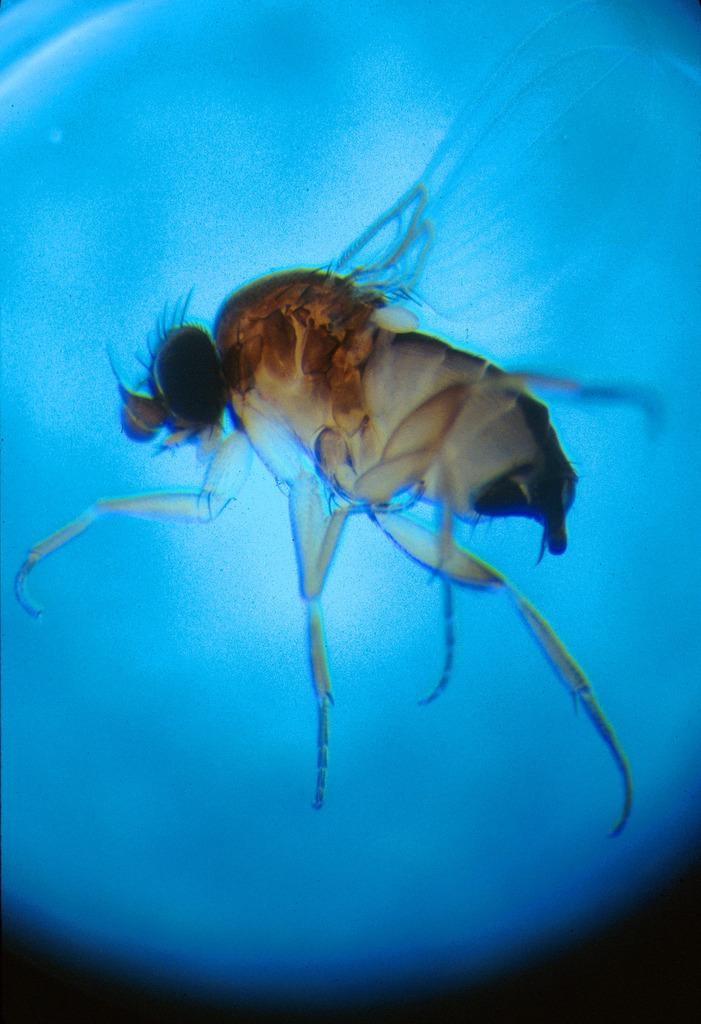What type of insect is in the image? There is a phorid fly in the image. What color is the background of the image? The background of the image is blue. What type of zebra can be seen in the image? There is no zebra present in the image; it features a phorid fly. What historical event is depicted in the image? There is no historical event depicted in the image; it features a phorid fly against a blue background. 